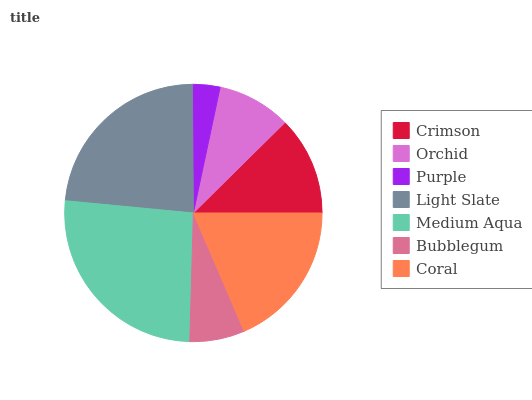Is Purple the minimum?
Answer yes or no. Yes. Is Medium Aqua the maximum?
Answer yes or no. Yes. Is Orchid the minimum?
Answer yes or no. No. Is Orchid the maximum?
Answer yes or no. No. Is Crimson greater than Orchid?
Answer yes or no. Yes. Is Orchid less than Crimson?
Answer yes or no. Yes. Is Orchid greater than Crimson?
Answer yes or no. No. Is Crimson less than Orchid?
Answer yes or no. No. Is Crimson the high median?
Answer yes or no. Yes. Is Crimson the low median?
Answer yes or no. Yes. Is Bubblegum the high median?
Answer yes or no. No. Is Coral the low median?
Answer yes or no. No. 